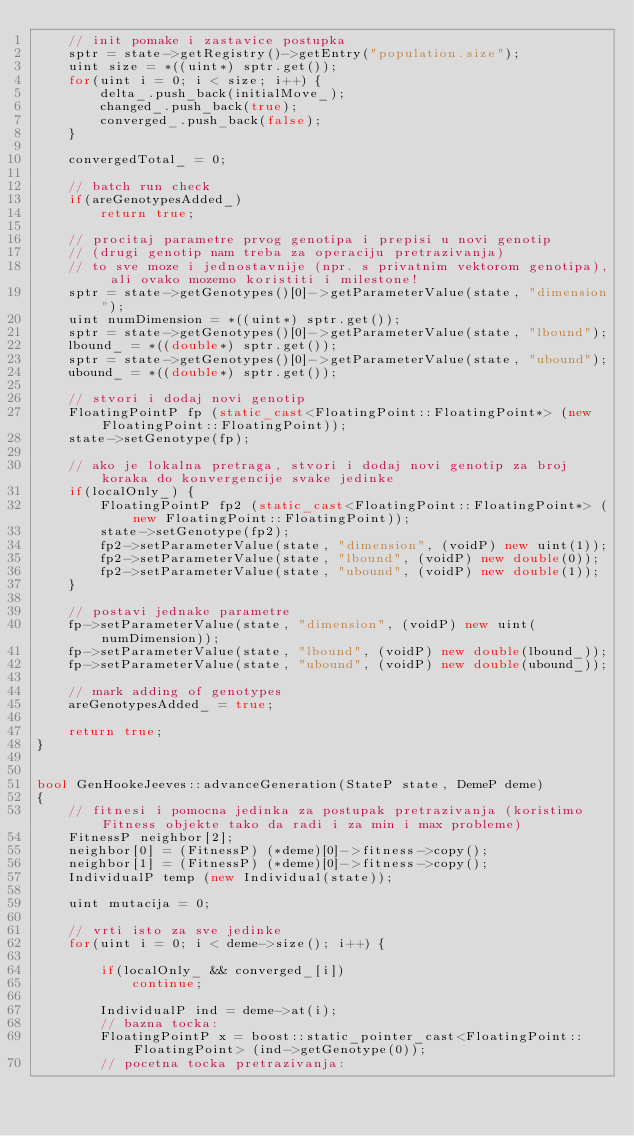<code> <loc_0><loc_0><loc_500><loc_500><_C++_>	// init pomake i zastavice postupka
	sptr = state->getRegistry()->getEntry("population.size");
	uint size = *((uint*) sptr.get());
	for(uint i = 0; i < size; i++) {
		delta_.push_back(initialMove_);
		changed_.push_back(true);
		converged_.push_back(false);
	}

	convergedTotal_ = 0;

	// batch run check
	if(areGenotypesAdded_)
		return true;

	// procitaj parametre prvog genotipa i prepisi u novi genotip
	// (drugi genotip nam treba za operaciju pretrazivanja)
	// to sve moze i jednostavnije (npr. s privatnim vektorom genotipa), ali ovako mozemo koristiti i milestone!
	sptr = state->getGenotypes()[0]->getParameterValue(state, "dimension");
	uint numDimension = *((uint*) sptr.get());
	sptr = state->getGenotypes()[0]->getParameterValue(state, "lbound");
	lbound_ = *((double*) sptr.get());
	sptr = state->getGenotypes()[0]->getParameterValue(state, "ubound");
	ubound_ = *((double*) sptr.get());

	// stvori i dodaj novi genotip
	FloatingPointP fp (static_cast<FloatingPoint::FloatingPoint*> (new FloatingPoint::FloatingPoint));
	state->setGenotype(fp);

	// ako je lokalna pretraga, stvori i dodaj novi genotip za broj koraka do konvergencije svake jedinke
	if(localOnly_) {
		FloatingPointP fp2 (static_cast<FloatingPoint::FloatingPoint*> (new FloatingPoint::FloatingPoint));
		state->setGenotype(fp2);
		fp2->setParameterValue(state, "dimension", (voidP) new uint(1));
		fp2->setParameterValue(state, "lbound", (voidP) new double(0));
		fp2->setParameterValue(state, "ubound", (voidP) new double(1));
	}

	// postavi jednake parametre
	fp->setParameterValue(state, "dimension", (voidP) new uint(numDimension));
	fp->setParameterValue(state, "lbound", (voidP) new double(lbound_));
	fp->setParameterValue(state, "ubound", (voidP) new double(ubound_));

	// mark adding of genotypes
	areGenotypesAdded_ = true;

	return true;
}


bool GenHookeJeeves::advanceGeneration(StateP state, DemeP deme)
{
	// fitnesi i pomocna jedinka za postupak pretrazivanja (koristimo Fitness objekte tako da radi i za min i max probleme)
	FitnessP neighbor[2];
	neighbor[0] = (FitnessP) (*deme)[0]->fitness->copy();
	neighbor[1] = (FitnessP) (*deme)[0]->fitness->copy();
	IndividualP temp (new Individual(state));

	uint mutacija = 0;

	// vrti isto za sve jedinke
	for(uint i = 0; i < deme->size(); i++) {

		if(localOnly_ && converged_[i])
			continue;

		IndividualP ind = deme->at(i);
		// bazna tocka:
		FloatingPointP x = boost::static_pointer_cast<FloatingPoint::FloatingPoint> (ind->getGenotype(0));
		// pocetna tocka pretrazivanja:</code> 